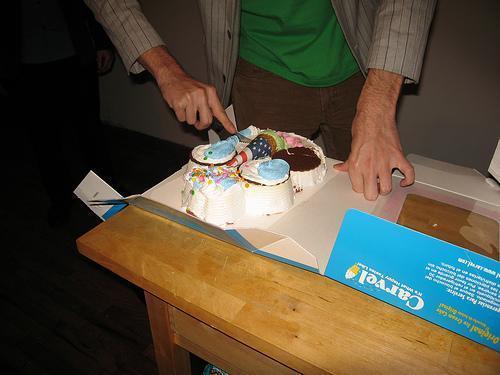How many cakes are in the picture?
Give a very brief answer. 1. How many people are in the picture?
Give a very brief answer. 1. How many cake boxes are in the picture?
Give a very brief answer. 1. 